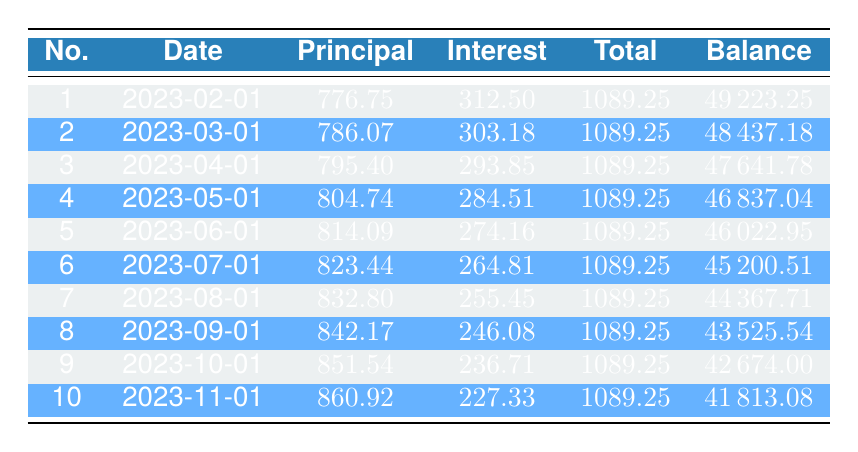What is the total payment made in the first month of the loan? From the table, we can see that the total payment for the first month (payment number 1) is listed as 1089.25.
Answer: 1089.25 What is the remaining balance after the second payment? According to the table, after the second payment (payment number 2), the remaining balance is 48437.18.
Answer: 48437.18 How much did the principal payment increase from the first month to the tenth month? The principal payment in the first month is 776.75, and in the tenth month, it is 860.92. To find the increase: 860.92 - 776.75 = 84.17.
Answer: 84.17 Is the interest payment in the third month higher than the interest payment in the fourth month? In the third month, the interest payment is 293.85, while in the fourth month, it is 284.51. Since 293.85 is greater than 284.51, the answer is yes.
Answer: Yes What is the average principal payment over the first five months? To find the average principal payment, sum the principal payments for the first five months: 776.75 + 786.07 + 795.40 + 804.74 + 814.09 = 3977.05. Then divide by 5: 3977.05 / 5 = 795.41.
Answer: 795.41 How much total interest was paid in the first three months? The total interest paid in the first three months can be calculated by adding up the interest payments for those months: 312.50 + 303.18 + 293.85 = 909.53.
Answer: 909.53 What was the total amount paid in principal over the first six months? The total principal payment over the first six months is the sum of the principal payments for those months: 776.75 + 786.07 + 795.40 + 804.74 + 814.09 + 823.44 = 5000.49.
Answer: 5000.49 Is the remaining balance after the fifth payment less than 46000? After the fifth payment, the remaining balance is 46022.95. Since 46022.95 is greater than 46000, the answer is no.
Answer: No What is the total amount of payments made after the first 10 months? To find the total payments made after the first 10 months, we simply multiply the total payment per month by 10: 1089.25 * 10 = 10892.50.
Answer: 10892.50 